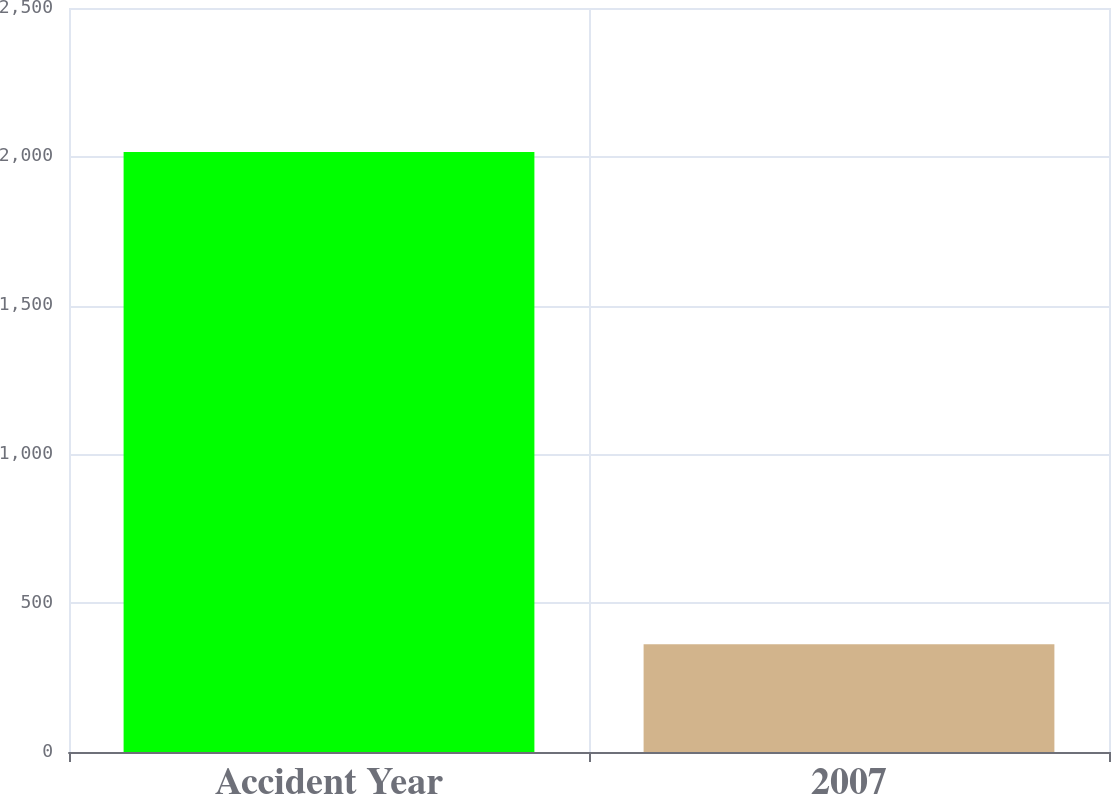Convert chart to OTSL. <chart><loc_0><loc_0><loc_500><loc_500><bar_chart><fcel>Accident Year<fcel>2007<nl><fcel>2016<fcel>362<nl></chart> 